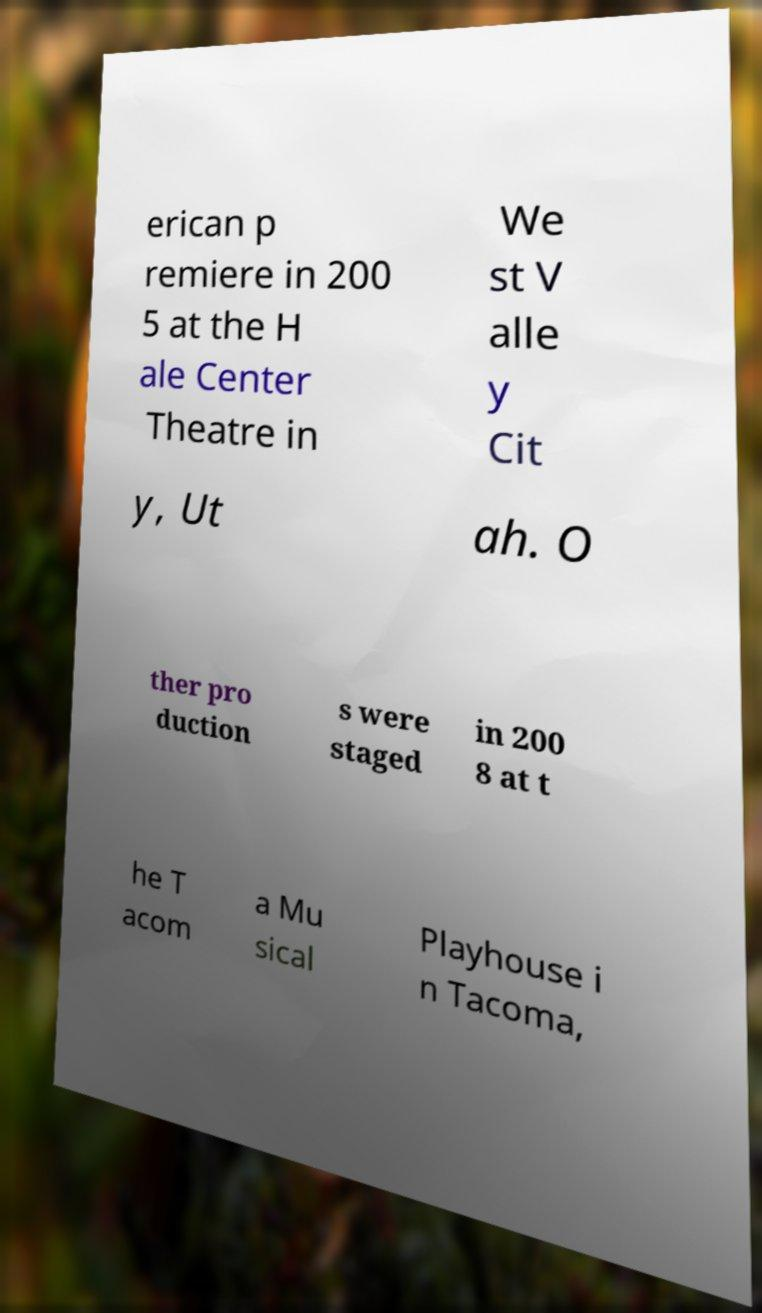There's text embedded in this image that I need extracted. Can you transcribe it verbatim? erican p remiere in 200 5 at the H ale Center Theatre in We st V alle y Cit y, Ut ah. O ther pro duction s were staged in 200 8 at t he T acom a Mu sical Playhouse i n Tacoma, 